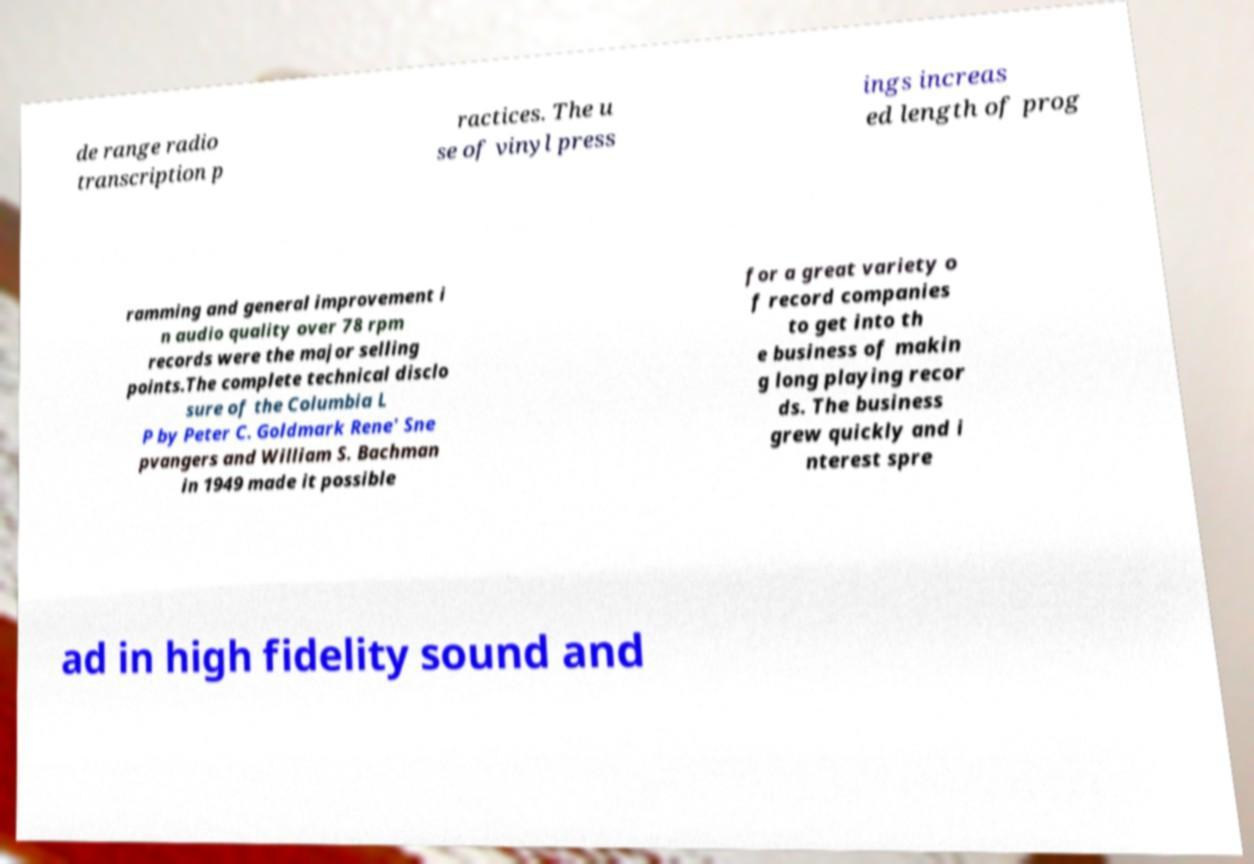Can you accurately transcribe the text from the provided image for me? de range radio transcription p ractices. The u se of vinyl press ings increas ed length of prog ramming and general improvement i n audio quality over 78 rpm records were the major selling points.The complete technical disclo sure of the Columbia L P by Peter C. Goldmark Rene' Sne pvangers and William S. Bachman in 1949 made it possible for a great variety o f record companies to get into th e business of makin g long playing recor ds. The business grew quickly and i nterest spre ad in high fidelity sound and 